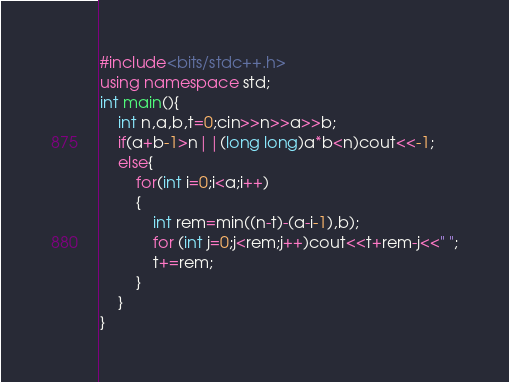Convert code to text. <code><loc_0><loc_0><loc_500><loc_500><_C++_>#include<bits/stdc++.h>
using namespace std;
int main(){
	int n,a,b,t=0;cin>>n>>a>>b;
	if(a+b-1>n||(long long)a*b<n)cout<<-1;
	else{
		for(int i=0;i<a;i++)
		{
			int rem=min((n-t)-(a-i-1),b);
			for (int j=0;j<rem;j++)cout<<t+rem-j<<" ";
			t+=rem;
		}
	}
}
</code> 